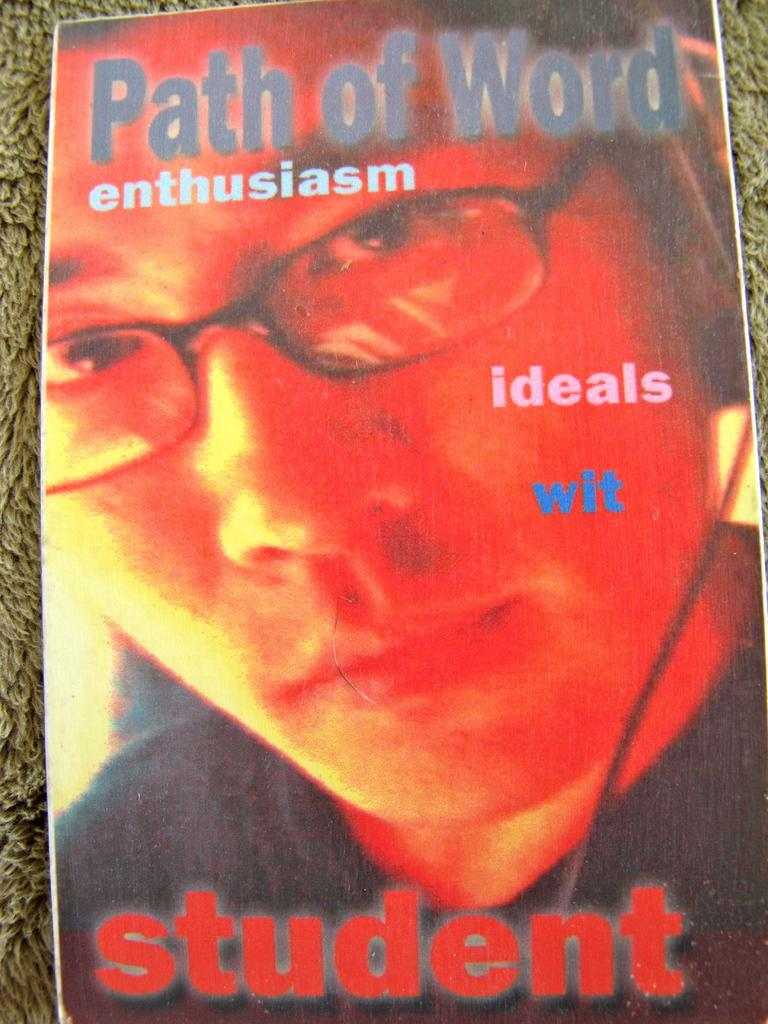What is present in the image that features text or graphics? There is a poster in the image. Where is the poster located? The poster is on a surface. What can be seen on the poster? There is a person wearing specs on the poster. What else is featured on the poster besides the person? There is writing on the poster. What is the position of the thumb on the poster? There is no thumb present on the poster; it only features a person wearing specs and writing. 